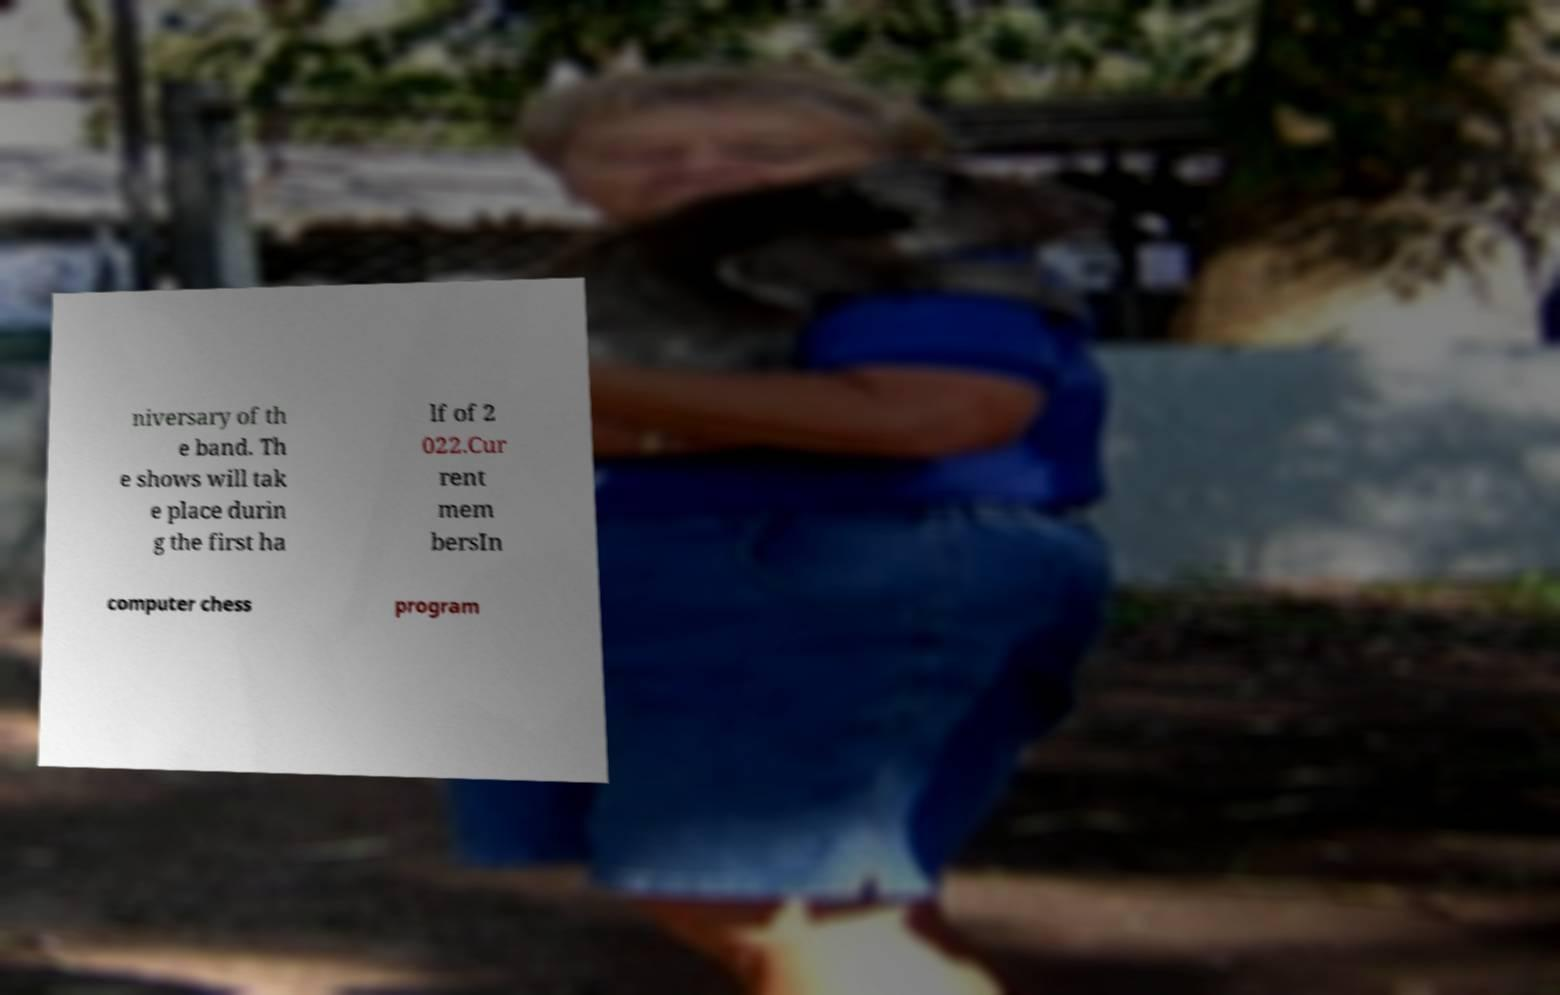What messages or text are displayed in this image? I need them in a readable, typed format. niversary of th e band. Th e shows will tak e place durin g the first ha lf of 2 022.Cur rent mem bersIn computer chess program 